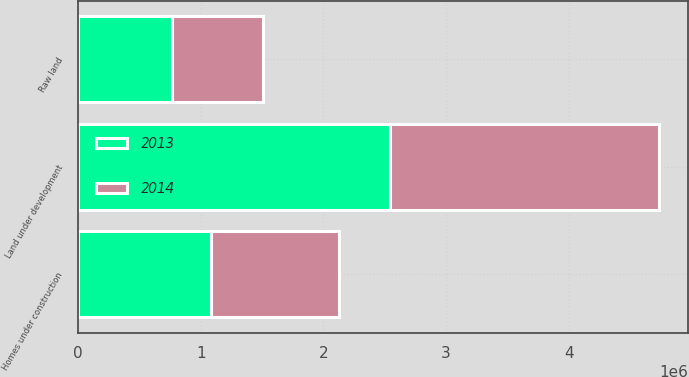Convert chart to OTSL. <chart><loc_0><loc_0><loc_500><loc_500><stacked_bar_chart><ecel><fcel>Homes under construction<fcel>Land under development<fcel>Raw land<nl><fcel>2013<fcel>1.08414e+06<fcel>2.54505e+06<fcel>762914<nl><fcel>2014<fcel>1.04215e+06<fcel>2.18939e+06<fcel>747027<nl></chart> 